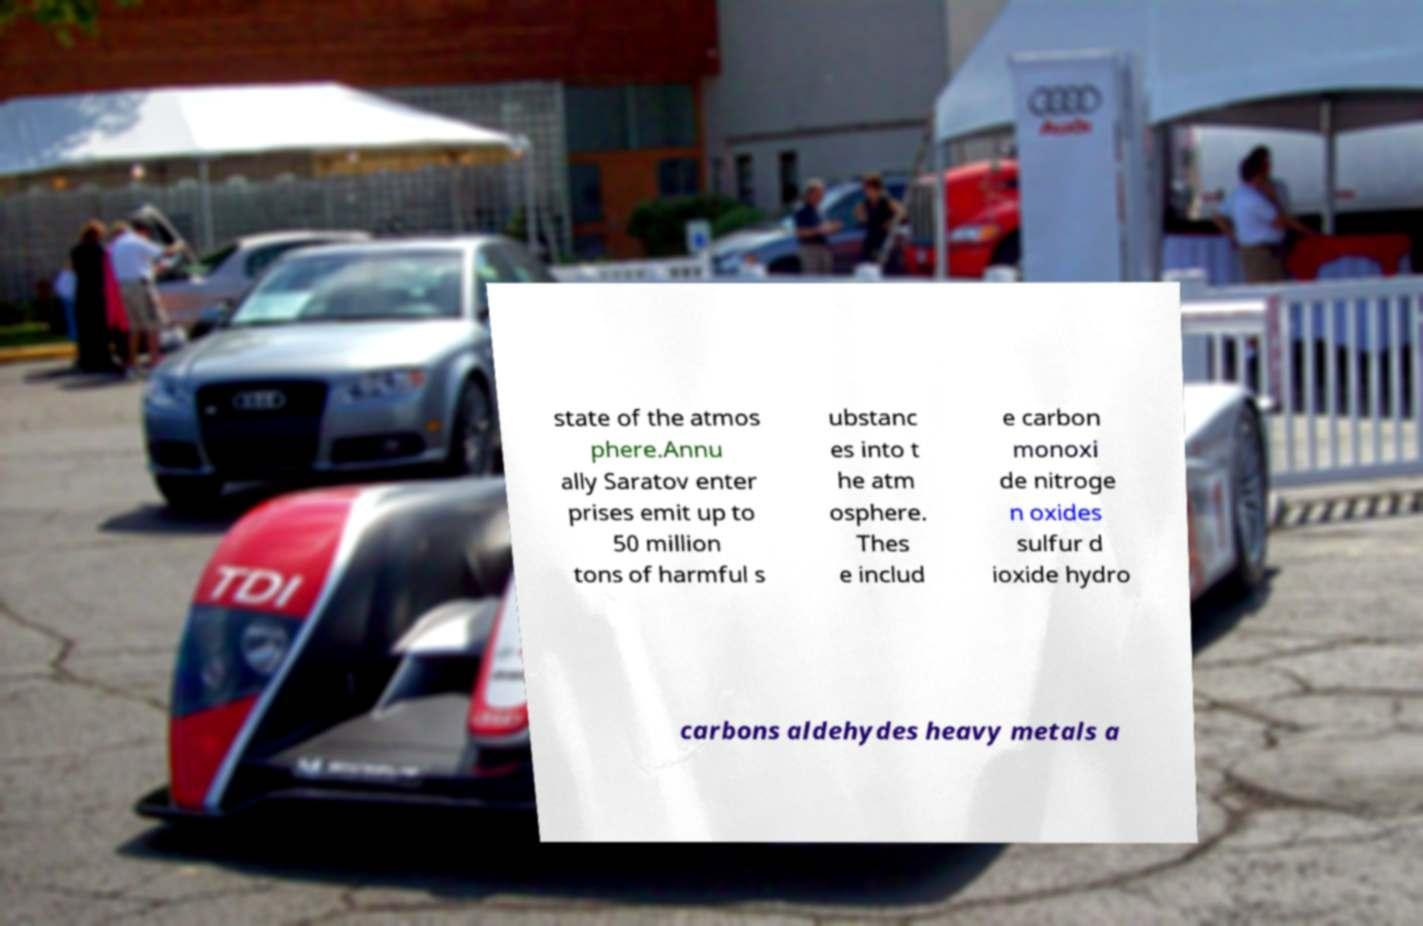Can you read and provide the text displayed in the image?This photo seems to have some interesting text. Can you extract and type it out for me? state of the atmos phere.Annu ally Saratov enter prises emit up to 50 million tons of harmful s ubstanc es into t he atm osphere. Thes e includ e carbon monoxi de nitroge n oxides sulfur d ioxide hydro carbons aldehydes heavy metals a 